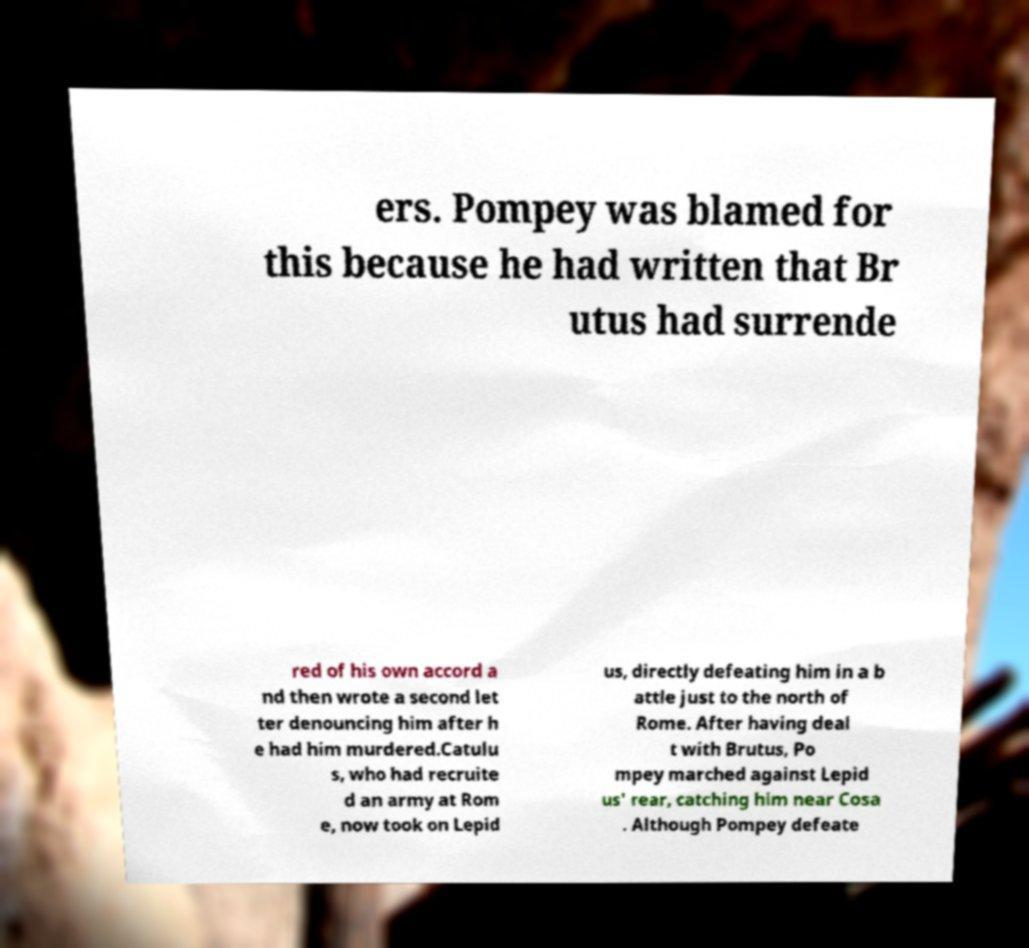Please read and relay the text visible in this image. What does it say? ers. Pompey was blamed for this because he had written that Br utus had surrende red of his own accord a nd then wrote a second let ter denouncing him after h e had him murdered.Catulu s, who had recruite d an army at Rom e, now took on Lepid us, directly defeating him in a b attle just to the north of Rome. After having deal t with Brutus, Po mpey marched against Lepid us' rear, catching him near Cosa . Although Pompey defeate 